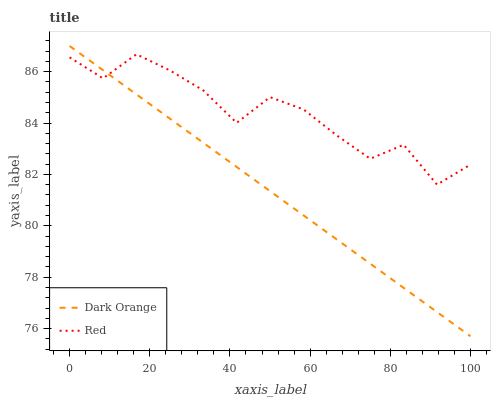Does Dark Orange have the minimum area under the curve?
Answer yes or no. Yes. Does Red have the maximum area under the curve?
Answer yes or no. Yes. Does Red have the minimum area under the curve?
Answer yes or no. No. Is Dark Orange the smoothest?
Answer yes or no. Yes. Is Red the roughest?
Answer yes or no. Yes. Is Red the smoothest?
Answer yes or no. No. Does Dark Orange have the lowest value?
Answer yes or no. Yes. Does Red have the lowest value?
Answer yes or no. No. Does Dark Orange have the highest value?
Answer yes or no. Yes. Does Red have the highest value?
Answer yes or no. No. Does Dark Orange intersect Red?
Answer yes or no. Yes. Is Dark Orange less than Red?
Answer yes or no. No. Is Dark Orange greater than Red?
Answer yes or no. No. 